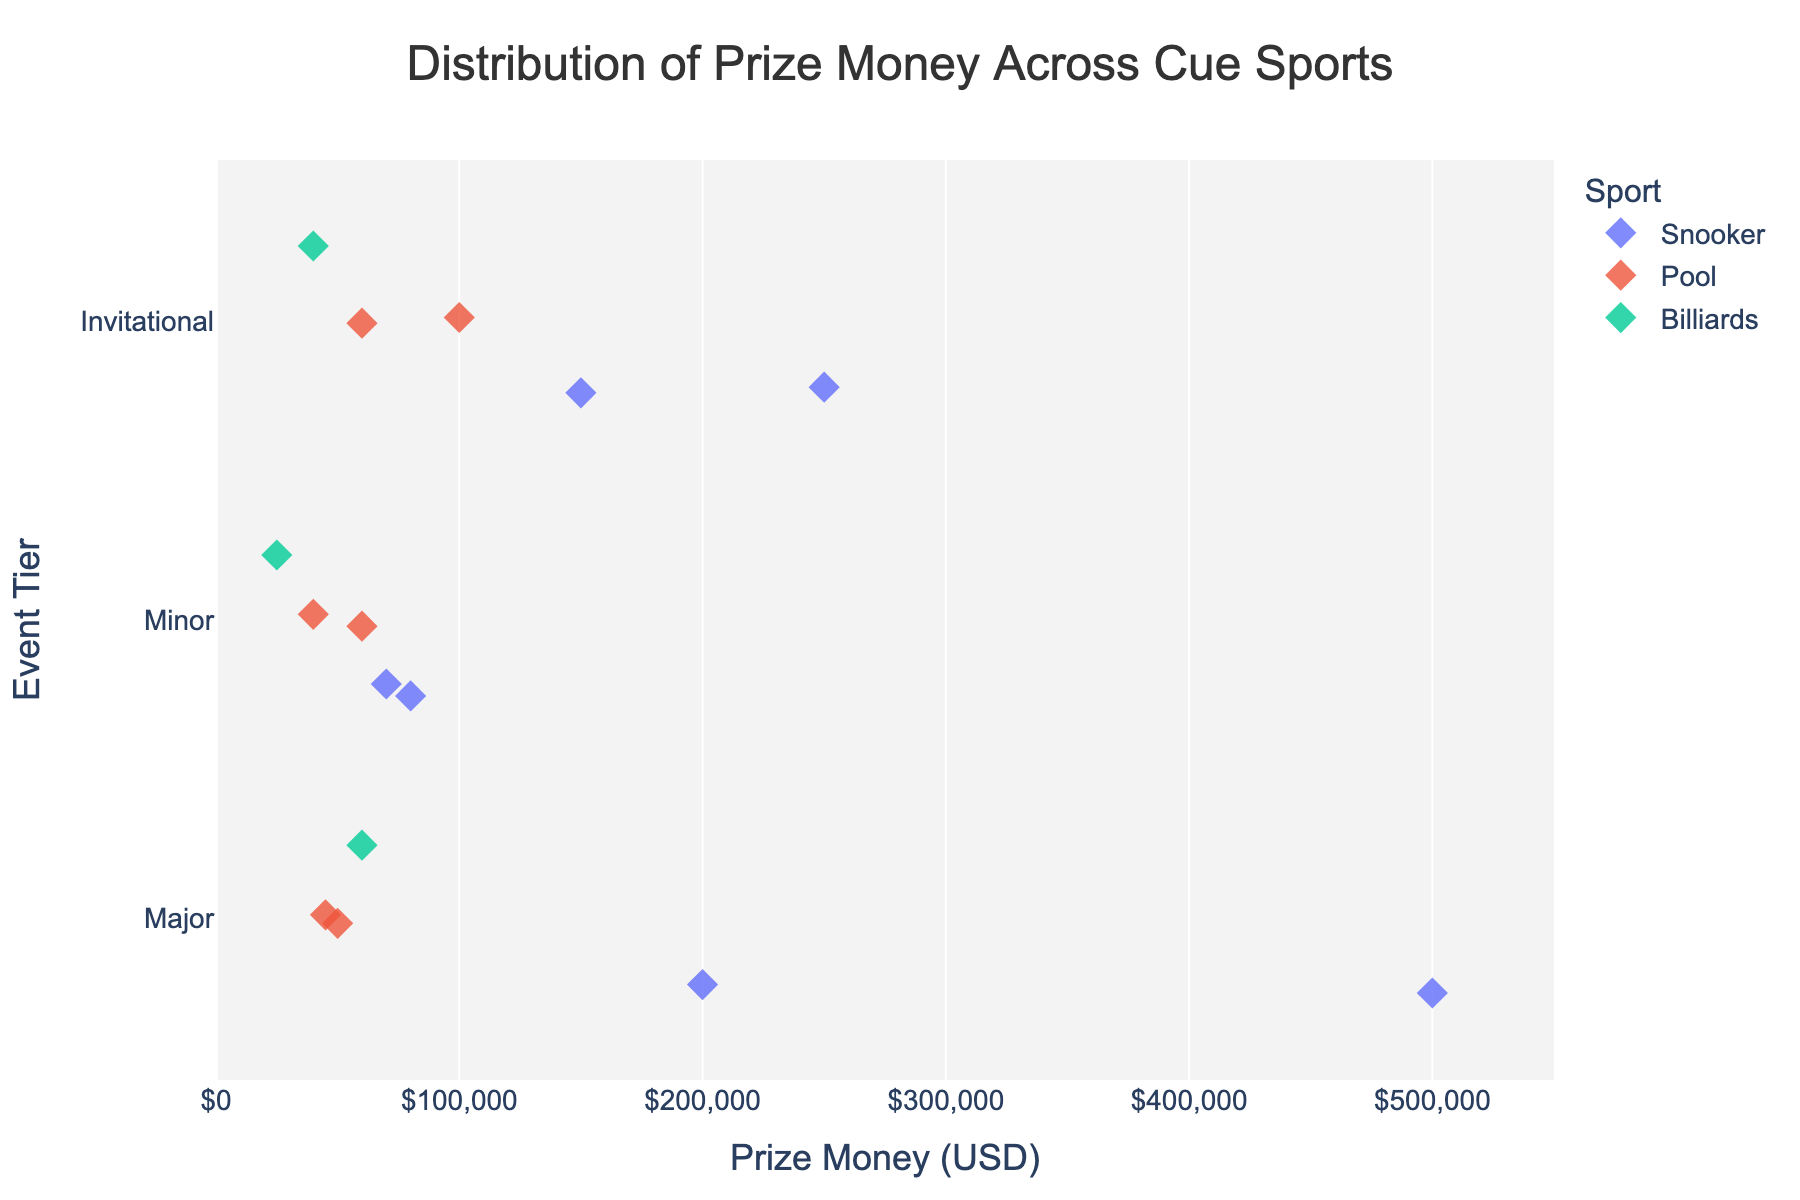What is the prize money range of the tournaments in the 'Major' tier? To determine the prize money range for 'Major' tier tournaments, we look at the minimum and maximum prize money values in that tier. The minimum is $45,000 (World 9-Ball Championship) and the maximum is $500,000 (World Snooker Championship).
Answer: $45,000 to $500,000 Which cue sport has the highest prize money in the 'Invitational' tier? To find the highest prize money in the 'Invitational' tier, we look at the prize money values of tournaments in that tier and identify the highest one. The 'Masters' tournament in Snooker has $250,000, which is the highest.
Answer: Snooker How does the prize money for Snooker in 'Minor' tier compare to that of Pool in 'Minor' tier? We compare the prize money values for Snooker and Pool in the 'Minor' tier. For Snooker, the Welsh Open and German Masters have $70,000 and $80,000 respectively. For Pool, World Pool Masters and China Open 9-Ball have $60,000 and $40,000 respectively. Snooker has higher prize money.
Answer: Snooker has higher prize money What is the average prize money of all 'Invitational' tier tournaments? To find the average prize money of 'Invitational' tier tournaments, we sum the prize money values and divide by the number of tournaments in this tier. The prize values are $250,000, $150,000, $100,000, $60,000, and $40,000. Their sum is $600,000 and there are 5 tournaments. So, the average is $600,000 / 5 = $120,000.
Answer: $120,000 Between Snooker and Pool in the 'Major' tier, which has the higher overall prize money? To determine which has the higher overall prize money, we sum up the prize money values for each sport in the 'Major' tier. Snooker: $500,000 (World Snooker Championship) + $200,000 (UK Championship) = $700,000. Pool: $50,000 (US Open 9-Ball) + $45,000 (World 9-Ball) = $95,000. Snooker has higher overall prize money.
Answer: Snooker What is the total prize money offered in 'Minor' tier tournaments? To find the total prize money for 'Minor' tier tournaments, we sum up the prize money values in that tier. The values are $70,000, $80,000, $60,000, $40,000, and $25,000. Total prize money is $275,000.
Answer: $275,000 Which tournament offers the highest prize money across all cue sports and event tiers? To find the tournament with the highest prize money, we identify the maximum value across all data points. The highest prize money is $500,000, offered by the World Snooker Championship.
Answer: World Snooker Championship Is the prize money for the Mosconi Cup higher or lower than the Champion of Champions tournament? We compare the prize money values of the Mosconi Cup ($100,000) and the Champion of Champions ($150,000) tournaments. The Mosconi Cup has lower prize money.
Answer: Lower 